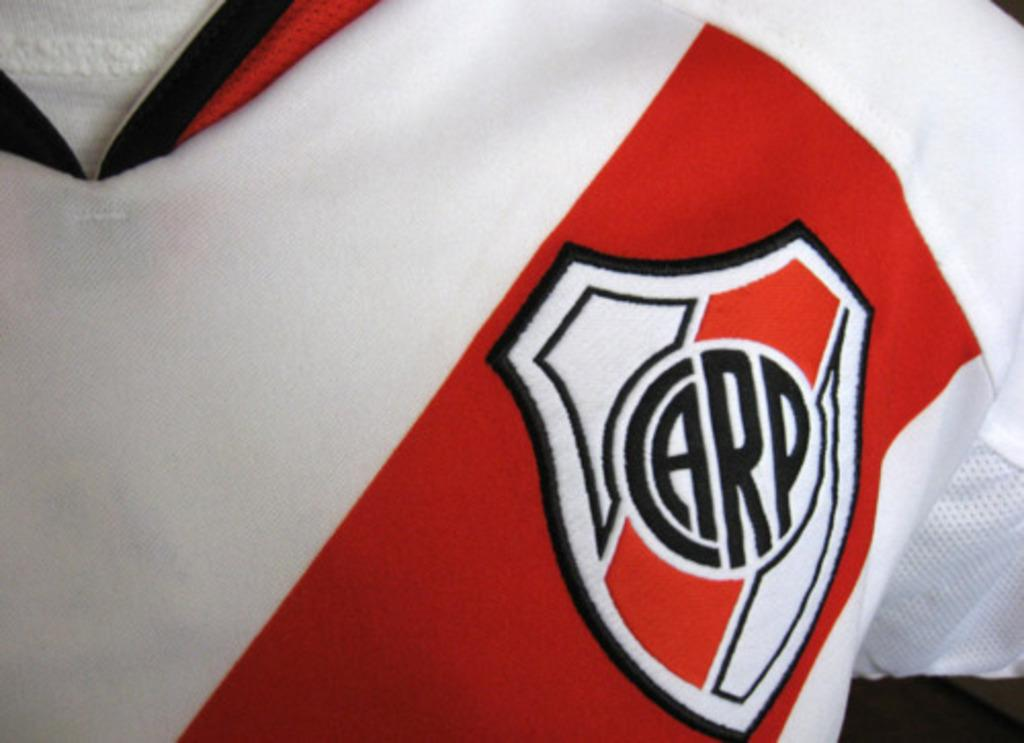Provide a one-sentence caption for the provided image. Red and white shirt which says the word CARP on it. 